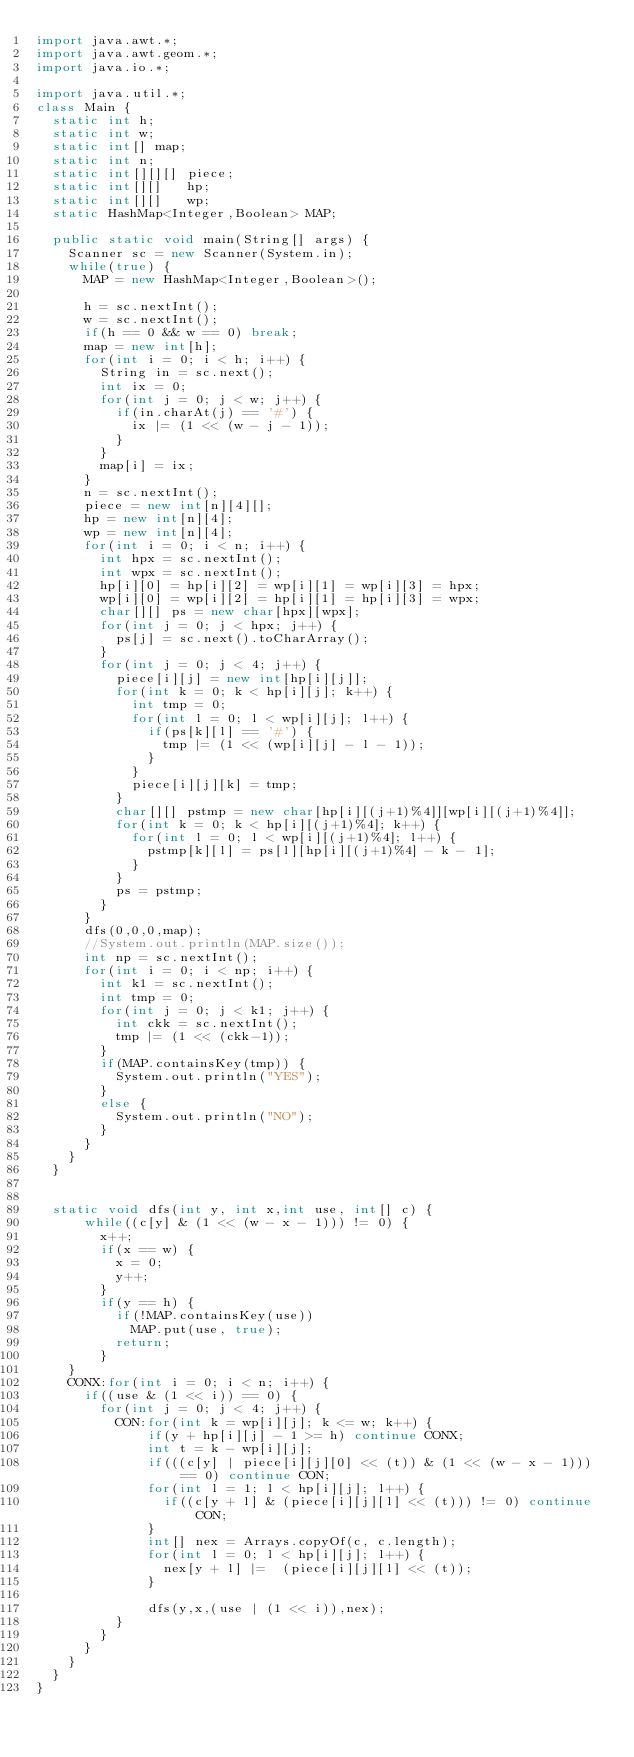Convert code to text. <code><loc_0><loc_0><loc_500><loc_500><_Java_>import java.awt.*;
import java.awt.geom.*;
import java.io.*;

import java.util.*;
class Main {
	static int h;
	static int w;
	static int[] map;
	static int n;
	static int[][][] piece;
	static int[][]   hp;
	static int[][]   wp;
	static HashMap<Integer,Boolean> MAP;

	public static void main(String[] args) {
		Scanner sc = new Scanner(System.in);
		while(true) {
			MAP = new HashMap<Integer,Boolean>();
			
			h = sc.nextInt();
			w = sc.nextInt();
			if(h == 0 && w == 0) break;
			map = new int[h];
			for(int i = 0; i < h; i++) {
				String in = sc.next();
				int ix = 0;
				for(int j = 0; j < w; j++) {
					if(in.charAt(j) == '#') {
						ix |= (1 << (w - j - 1));
					}
				}
				map[i] = ix;
			}
			n = sc.nextInt();
			piece = new int[n][4][];
			hp = new int[n][4];
			wp = new int[n][4];
			for(int i = 0; i < n; i++) {
				int hpx = sc.nextInt();
				int wpx = sc.nextInt();
				hp[i][0] = hp[i][2] = wp[i][1] = wp[i][3] = hpx;
				wp[i][0] = wp[i][2] = hp[i][1] = hp[i][3] = wpx;
				char[][] ps = new char[hpx][wpx];
				for(int j = 0; j < hpx; j++) {
					ps[j] = sc.next().toCharArray();
				}
				for(int j = 0; j < 4; j++) {
					piece[i][j] = new int[hp[i][j]];
					for(int k = 0; k < hp[i][j]; k++) {
						int tmp = 0;
						for(int l = 0; l < wp[i][j]; l++) {
							if(ps[k][l] == '#') {
								tmp |= (1 << (wp[i][j] - l - 1));
							}
						}
						piece[i][j][k] = tmp;
					}
					char[][] pstmp = new char[hp[i][(j+1)%4]][wp[i][(j+1)%4]];
					for(int k = 0; k < hp[i][(j+1)%4]; k++) {
						for(int l = 0; l < wp[i][(j+1)%4]; l++) {
							pstmp[k][l] = ps[l][hp[i][(j+1)%4] - k - 1];
						}
					}
					ps = pstmp;
				}
			}
			dfs(0,0,0,map);
			//System.out.println(MAP.size());
			int np = sc.nextInt();
			for(int i = 0; i < np; i++) {
				int k1 = sc.nextInt();
				int tmp = 0;
				for(int j = 0; j < k1; j++) {
					int ckk = sc.nextInt();
					tmp |= (1 << (ckk-1));
				}
				if(MAP.containsKey(tmp)) {
					System.out.println("YES");
				}
				else {
					System.out.println("NO");
				}
			}
		}
	}


	static void dfs(int y, int x,int use, int[] c) {
			while((c[y] & (1 << (w - x - 1))) != 0) {
				x++;
				if(x == w) {
					x = 0;
					y++;
				}
				if(y == h) {
					if(!MAP.containsKey(use))
						MAP.put(use, true);
					return;
				}
		}
		CONX:for(int i = 0; i < n; i++) {
			if((use & (1 << i)) == 0) {
				for(int j = 0; j < 4; j++) {
					CON:for(int k = wp[i][j]; k <= w; k++) {
							if(y + hp[i][j] - 1 >= h) continue CONX;
							int t = k - wp[i][j];
							if(((c[y] | piece[i][j][0] << (t)) & (1 << (w - x - 1))) == 0) continue CON;
							for(int l = 1; l < hp[i][j]; l++) {
								if((c[y + l] & (piece[i][j][l] << (t))) != 0) continue CON;
							}
							int[] nex = Arrays.copyOf(c, c.length);
							for(int l = 0; l < hp[i][j]; l++) {
								nex[y + l] |=  (piece[i][j][l] << (t));
							}
							
							dfs(y,x,(use | (1 << i)),nex);
					}
				}
			}
		}
	}
}</code> 